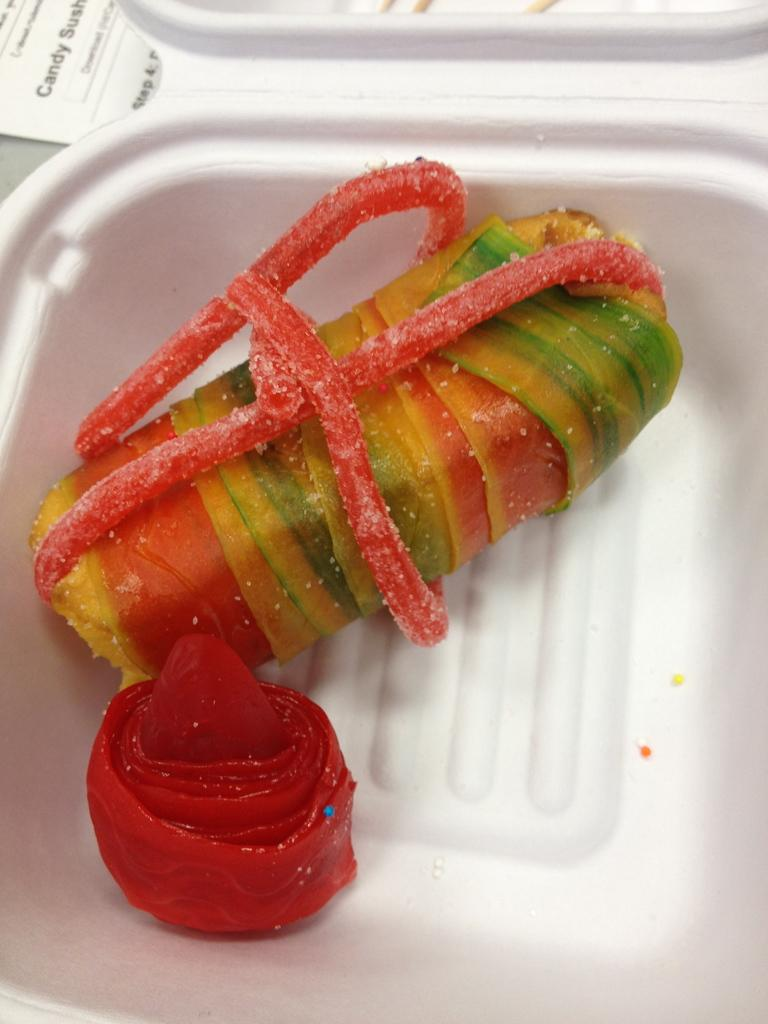What is present in the image? There is a bowl in the image. What is inside the bowl? The bowl contains objects. What type of mint can be seen growing in the image? There is no mint present in the image; the bowl contains objects, but no plants or vegetation are mentioned. 